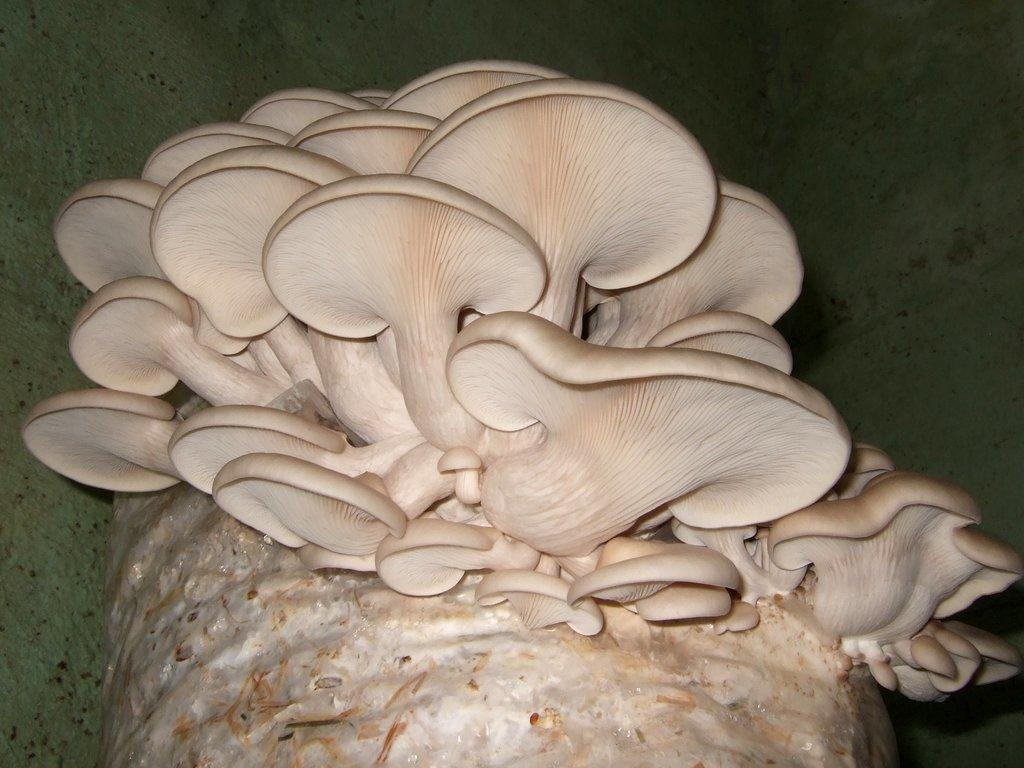What type of mushrooms are in the image? There are white colored mushrooms in the image. Where are the mushrooms located? The mushrooms are on a surface. What is the color of the background in the image? The background of the image is dark in color. What type of bike is visible in the image? There is no bike present in the image; it features white colored mushrooms on a surface with a dark background. 